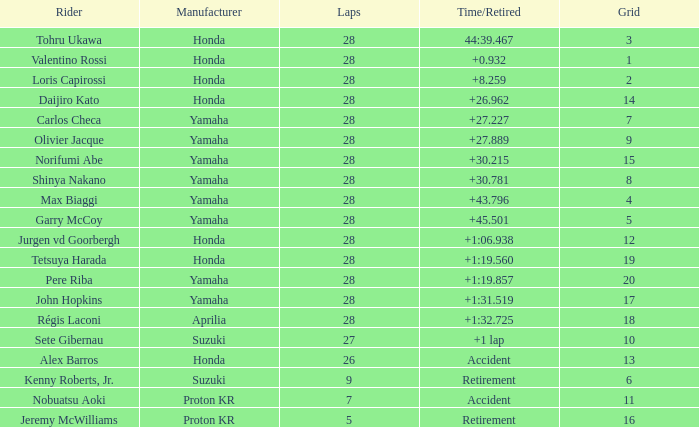Which Grid has Laps larger than 26, and a Time/Retired of 44:39.467? 3.0. 